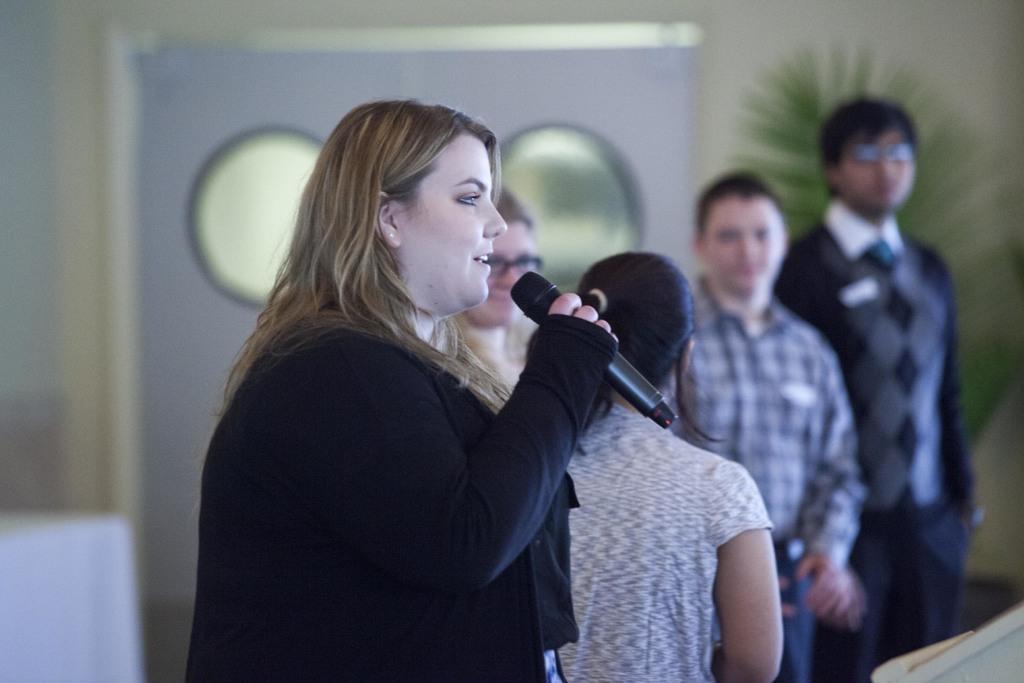Describe this image in one or two sentences. In this image I can see there is a group of persons. In the front there is a woman who is speaking in front of a microphone. 